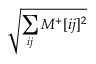Convert formula to latex. <formula><loc_0><loc_0><loc_500><loc_500>\sqrt { \sum _ { i j } M ^ { + } [ i j ] ^ { 2 } }</formula> 